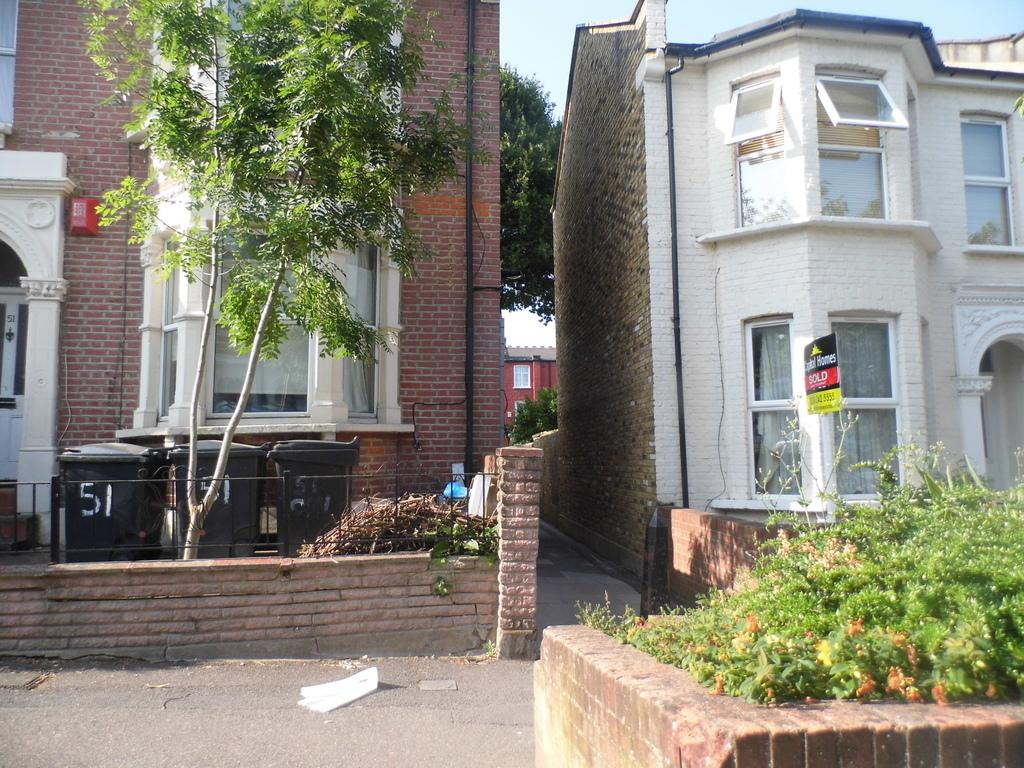What type of structures can be seen in the image? There are buildings in the image. What is located in front of the buildings? Trees and plants are present in front of the buildings. What is located behind the buildings? Trees are present behind the buildings. What can be seen above the buildings? The sky is visible above the buildings. Can you see any skateboarders performing tricks in space in the image? There is no reference to skateboarders or space in the image, so it is not possible to answer that question. 